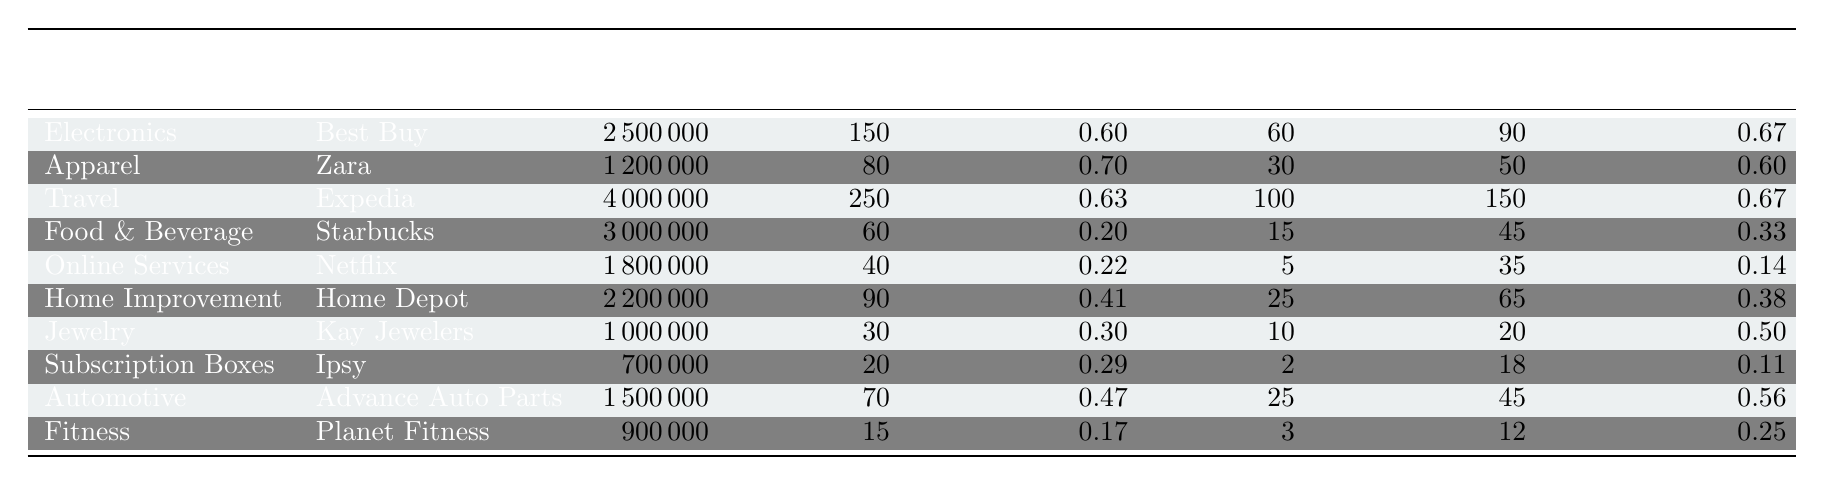What is the total number of chargebacks for Best Buy? The table shows that the total chargebacks for Best Buy, which falls under the Electronics category, is 150.
Answer: 150 Which merchant category has the highest chargeback rate? By comparing the chargeback rates across categories, Apparel (Zara) has a chargeback rate of 0.007, which is the highest among the listed categories.
Answer: Apparel What is the total sales amount for the Travel category? The total sales for the Travel category, represented by Expedia, is listed as 4,000,000 in the table.
Answer: 4000000 Is the chargeback rate for Starbucks higher than that for Ipsy? The chargeback rate for Starbucks is 0.002 (or 0.20%) while for Ipsy it is 0.00286 (or 0.29%). Therefore, the chargeback rate for Ipsy is higher than that for Starbucks.
Answer: No How many total fraudulent chargebacks are there across all merchants? To find the total fraudulent chargebacks, we sum the fraudulent chargebacks from each merchant: 60 + 30 + 100 + 15 + 5 + 25 + 10 + 2 + 25 + 3 = 275.
Answer: 275 What percentage of chargebacks for Home Depot are fraudulent? Home Depot has a total of 90 chargebacks, out of which 25 are fraudulent. The percentage is calculated as (25 / 90) * 100 = 27.78%.
Answer: 27.78% Which two merchants have the lowest chargeback rates, and what are those rates? The two merchants with the lowest chargeback rates are Planet Fitness at 0.00167 and Starbucks at 0.002.
Answer: Planet Fitness (0.00167) and Starbucks (0.002) What is the average chargeback rate across all merchants? The chargeback rates are: 0.006, 0.007, 0.00625, 0.002, 0.00222, 0.00409, 0.003, 0.00286, 0.00467, and 0.00167, totaling 0.04077. Dividing by the number of merchants (10) gives us an average chargeback rate of 0.004077.
Answer: 0.00408 Is the number of non-fraudulent chargebacks for Kay Jewelers greater than the number of fraudulent chargebacks? Kay Jewelers has 10 fraudulent chargebacks and 20 non-fraudulent chargebacks. Since 20 is greater than 10, the statement is true.
Answer: Yes Which merchant experienced the highest number of total sales to total chargebacks ratio? The ratio is calculated by dividing total sales by total chargebacks. For example, Best Buy's ratio is 2500000/150 = 16666.67. Comparing others, Expedia has the highest ratio with 16000.
Answer: Expedia 